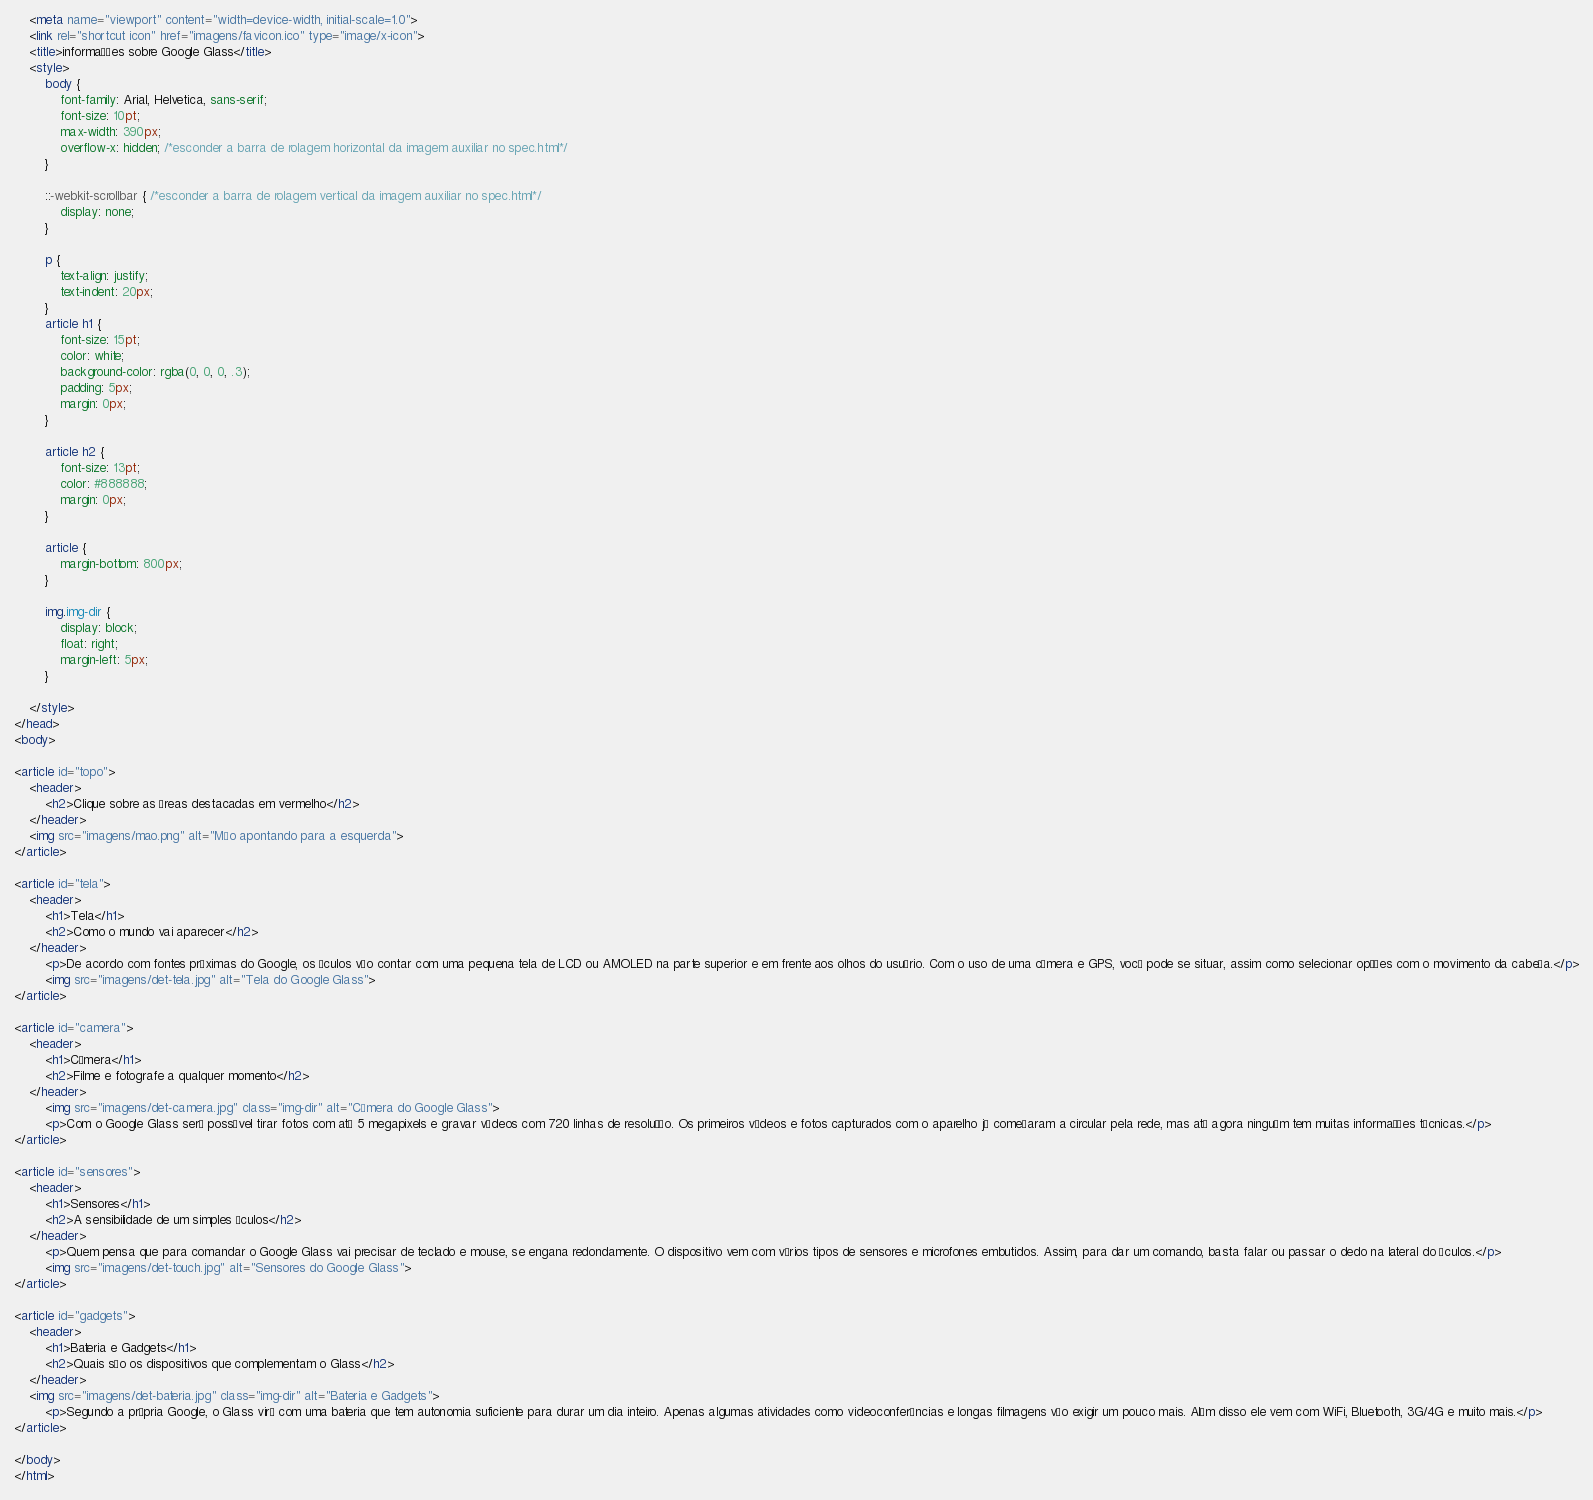Convert code to text. <code><loc_0><loc_0><loc_500><loc_500><_HTML_>    <meta name="viewport" content="width=device-width, initial-scale=1.0">
    <link rel="shortcut icon" href="imagens/favicon.ico" type="image/x-icon">
    <title>informações sobre Google Glass</title>
    <style>
        body {
            font-family: Arial, Helvetica, sans-serif;
            font-size: 10pt;   
            max-width: 390px;
            overflow-x: hidden; /*esconder a barra de rolagem horizontal da imagem auxiliar no spec.html*/
        }

        ::-webkit-scrollbar { /*esconder a barra de rolagem vertical da imagem auxiliar no spec.html*/
            display: none;
        }

        p {
            text-align: justify;
            text-indent: 20px;
        }
        article h1 {
            font-size: 15pt;
            color: white;
            background-color: rgba(0, 0, 0, .3);
            padding: 5px;
            margin: 0px;
        }

        article h2 {
            font-size: 13pt;
            color: #888888;
            margin: 0px;
        }

        article {
            margin-bottom: 800px;
        }

        img.img-dir {
            display: block;
            float: right;
            margin-left: 5px;
        }

    </style>
</head>
<body>
    
<article id="topo">
    <header>
        <h2>Clique sobre as áreas destacadas em vermelho</h2>
    </header>
    <img src="imagens/mao.png" alt="Mão apontando para a esquerda">
</article>

<article id="tela">
    <header>
        <h1>Tela</h1>
        <h2>Como o mundo vai aparecer</h2>
    </header>
        <p>De acordo com fontes próximas do Google, os óculos vão contar com uma pequena tela de LCD ou AMOLED na parte superior e em frente aos olhos do usuário. Com o uso de uma câmera e GPS, você pode se situar, assim como selecionar opções com o movimento da cabeça.</p>
        <img src="imagens/det-tela.jpg" alt="Tela do Google Glass"> 
</article>

<article id="camera">
    <header>
        <h1>Câmera</h1>
        <h2>Filme e fotografe a qualquer momento</h2>
    </header>
        <img src="imagens/det-camera.jpg" class="img-dir" alt="Câmera do Google Glass">
        <p>Com o Google Glass será possível tirar fotos com até 5 megapixels e gravar vídeos com 720 linhas de resolução. Os primeiros vídeos e fotos capturados com o aparelho já começaram a circular pela rede, mas até agora ninguém tem muitas informações técnicas.</p>
</article>

<article id="sensores">
    <header>
        <h1>Sensores</h1>
        <h2>A sensibilidade de um simples óculos</h2>
    </header>
        <p>Quem pensa que para comandar o Google Glass vai precisar de teclado e mouse, se engana redondamente. O dispositivo vem com vários tipos de sensores e microfones embutidos. Assim, para dar um comando, basta falar ou passar o dedo na lateral do óculos.</p>
        <img src="imagens/det-touch.jpg" alt="Sensores do Google Glass">
</article>

<article id="gadgets">
    <header>
        <h1>Bateria e Gadgets</h1>
        <h2>Quais são os dispositivos que complementam o Glass</h2>
    </header>
    <img src="imagens/det-bateria.jpg" class="img-dir" alt="Bateria e Gadgets">
        <p>Segundo a própria Google, o Glass virá com uma bateria que tem autonomia suficiente para durar um dia inteiro. Apenas algumas atividades como videoconferências e longas filmagens vão exigir um pouco mais. Além disso ele vem com WiFi, Bluetooth, 3G/4G e muito mais.</p>
</article>

</body>
</html></code> 